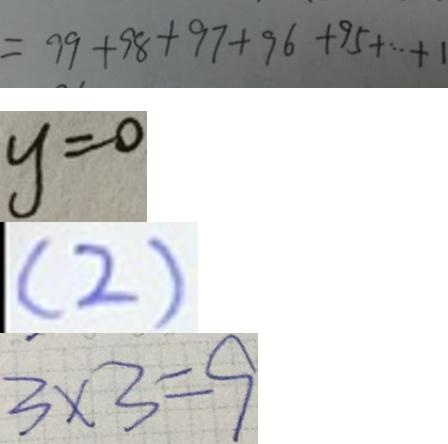<formula> <loc_0><loc_0><loc_500><loc_500>= 9 9 + 9 8 + 9 7 + 9 6 + 9 5 + \cdots + 1 
 y = 0 
 ( 2 ) 
 3 \times 3 = 9</formula> 